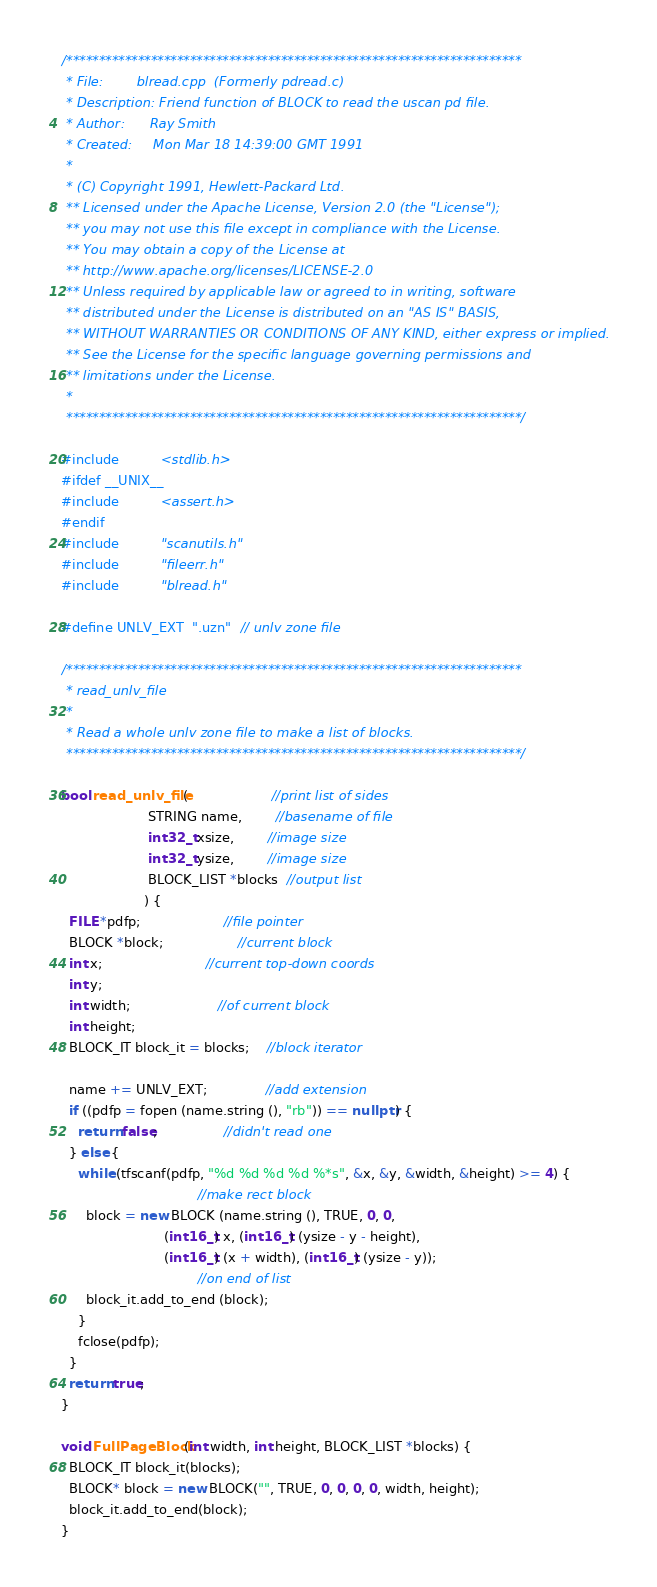Convert code to text. <code><loc_0><loc_0><loc_500><loc_500><_C++_>/**********************************************************************
 * File:        blread.cpp  (Formerly pdread.c)
 * Description: Friend function of BLOCK to read the uscan pd file.
 * Author:		Ray Smith
 * Created:		Mon Mar 18 14:39:00 GMT 1991
 *
 * (C) Copyright 1991, Hewlett-Packard Ltd.
 ** Licensed under the Apache License, Version 2.0 (the "License");
 ** you may not use this file except in compliance with the License.
 ** You may obtain a copy of the License at
 ** http://www.apache.org/licenses/LICENSE-2.0
 ** Unless required by applicable law or agreed to in writing, software
 ** distributed under the License is distributed on an "AS IS" BASIS,
 ** WITHOUT WARRANTIES OR CONDITIONS OF ANY KIND, either express or implied.
 ** See the License for the specific language governing permissions and
 ** limitations under the License.
 *
 **********************************************************************/

#include          <stdlib.h>
#ifdef __UNIX__
#include          <assert.h>
#endif
#include          "scanutils.h"
#include          "fileerr.h"
#include          "blread.h"

#define UNLV_EXT  ".uzn"  // unlv zone file

/**********************************************************************
 * read_unlv_file
 *
 * Read a whole unlv zone file to make a list of blocks.
 **********************************************************************/

bool read_unlv_file(                    //print list of sides
                     STRING name,        //basename of file
                     int32_t xsize,        //image size
                     int32_t ysize,        //image size
                     BLOCK_LIST *blocks  //output list
                    ) {
  FILE *pdfp;                    //file pointer
  BLOCK *block;                  //current block
  int x;                         //current top-down coords
  int y;
  int width;                     //of current block
  int height;
  BLOCK_IT block_it = blocks;    //block iterator

  name += UNLV_EXT;              //add extension
  if ((pdfp = fopen (name.string (), "rb")) == nullptr) {
    return false;                //didn't read one
  } else {
    while (tfscanf(pdfp, "%d %d %d %d %*s", &x, &y, &width, &height) >= 4) {
                                 //make rect block
      block = new BLOCK (name.string (), TRUE, 0, 0,
                         (int16_t) x, (int16_t) (ysize - y - height),
                         (int16_t) (x + width), (int16_t) (ysize - y));
                                 //on end of list
      block_it.add_to_end (block);
    }
    fclose(pdfp);
  }
  return true;
}

void FullPageBlock(int width, int height, BLOCK_LIST *blocks) {
  BLOCK_IT block_it(blocks);
  BLOCK* block = new BLOCK("", TRUE, 0, 0, 0, 0, width, height);
  block_it.add_to_end(block);
}
</code> 